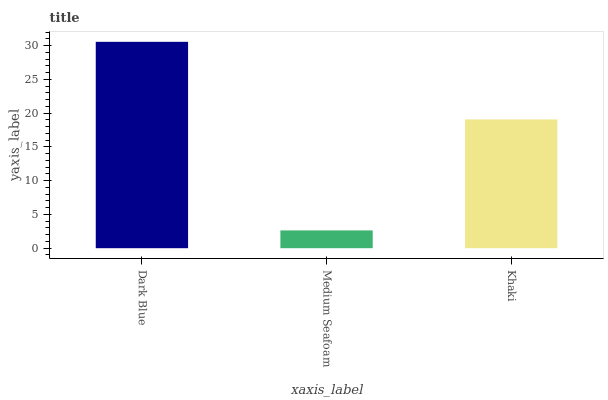Is Medium Seafoam the minimum?
Answer yes or no. Yes. Is Dark Blue the maximum?
Answer yes or no. Yes. Is Khaki the minimum?
Answer yes or no. No. Is Khaki the maximum?
Answer yes or no. No. Is Khaki greater than Medium Seafoam?
Answer yes or no. Yes. Is Medium Seafoam less than Khaki?
Answer yes or no. Yes. Is Medium Seafoam greater than Khaki?
Answer yes or no. No. Is Khaki less than Medium Seafoam?
Answer yes or no. No. Is Khaki the high median?
Answer yes or no. Yes. Is Khaki the low median?
Answer yes or no. Yes. Is Medium Seafoam the high median?
Answer yes or no. No. Is Dark Blue the low median?
Answer yes or no. No. 